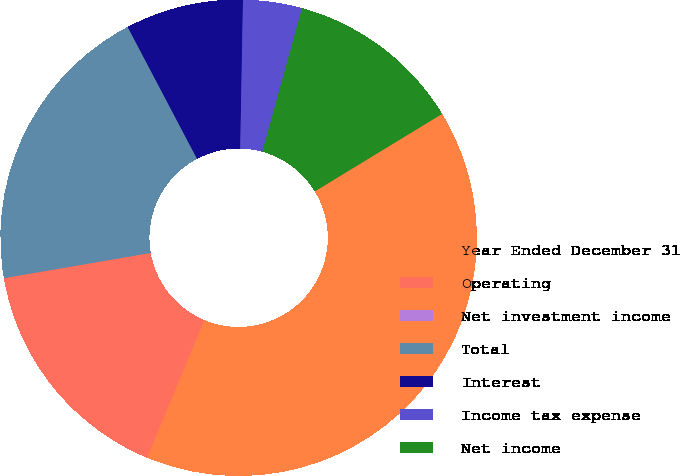Convert chart. <chart><loc_0><loc_0><loc_500><loc_500><pie_chart><fcel>Year Ended December 31<fcel>Operating<fcel>Net investment income<fcel>Total<fcel>Interest<fcel>Income tax expense<fcel>Net income<nl><fcel>39.99%<fcel>16.0%<fcel>0.0%<fcel>20.0%<fcel>8.0%<fcel>4.0%<fcel>12.0%<nl></chart> 